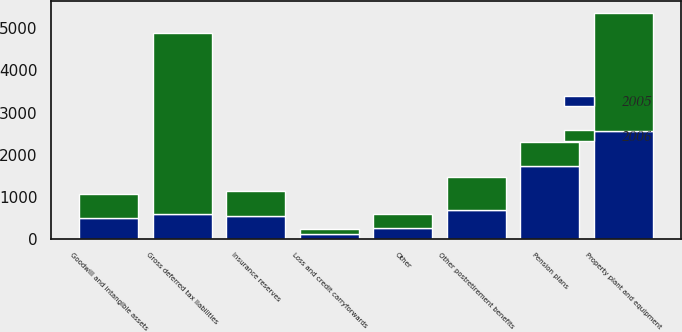Convert chart. <chart><loc_0><loc_0><loc_500><loc_500><stacked_bar_chart><ecel><fcel>Property plant and equipment<fcel>Goodwill and intangible assets<fcel>Pension plans<fcel>Other<fcel>Gross deferred tax liabilities<fcel>Other postretirement benefits<fcel>Loss and credit carryforwards<fcel>Insurance reserves<nl><fcel>2006<fcel>2802<fcel>578<fcel>579<fcel>343<fcel>4302<fcel>789<fcel>130<fcel>586<nl><fcel>2005<fcel>2572<fcel>491<fcel>1722<fcel>251<fcel>579<fcel>681<fcel>113<fcel>543<nl></chart> 